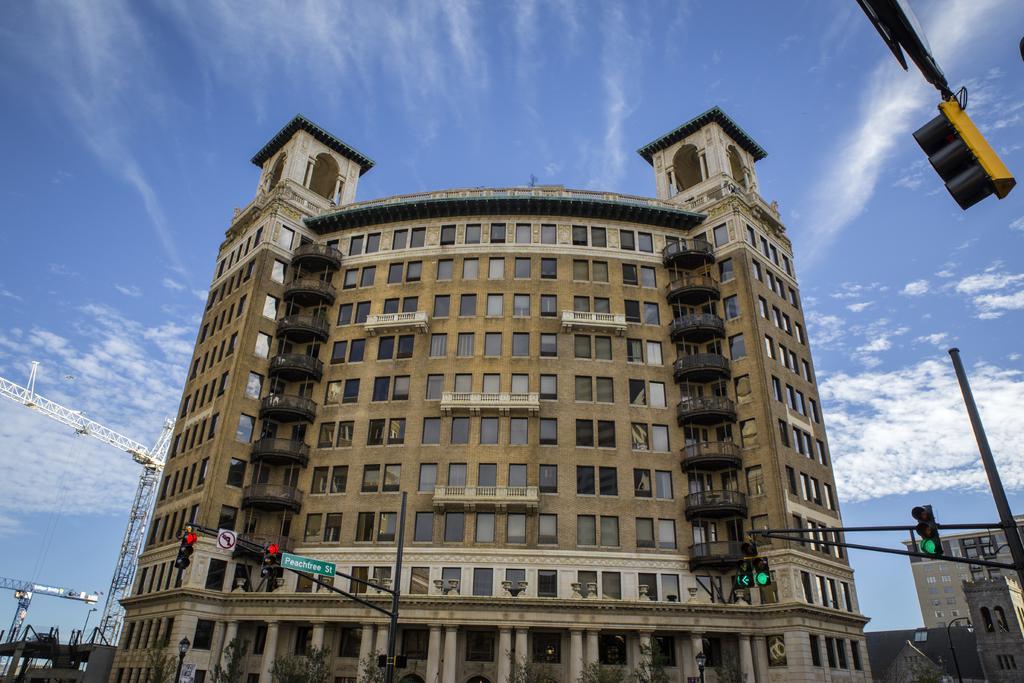Describe this image in one or two sentences. At the bottom, we see the poles, traffic signals and the light pole. On the right side, we see a traffic signal. In the middle, we see a building. On the left side, we see the poles and the crane towers. In the right top, we see a traffic pole. In the background, we see the clouds and the sky. 